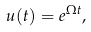<formula> <loc_0><loc_0><loc_500><loc_500>u ( t ) = e ^ { \Omega t } ,</formula> 